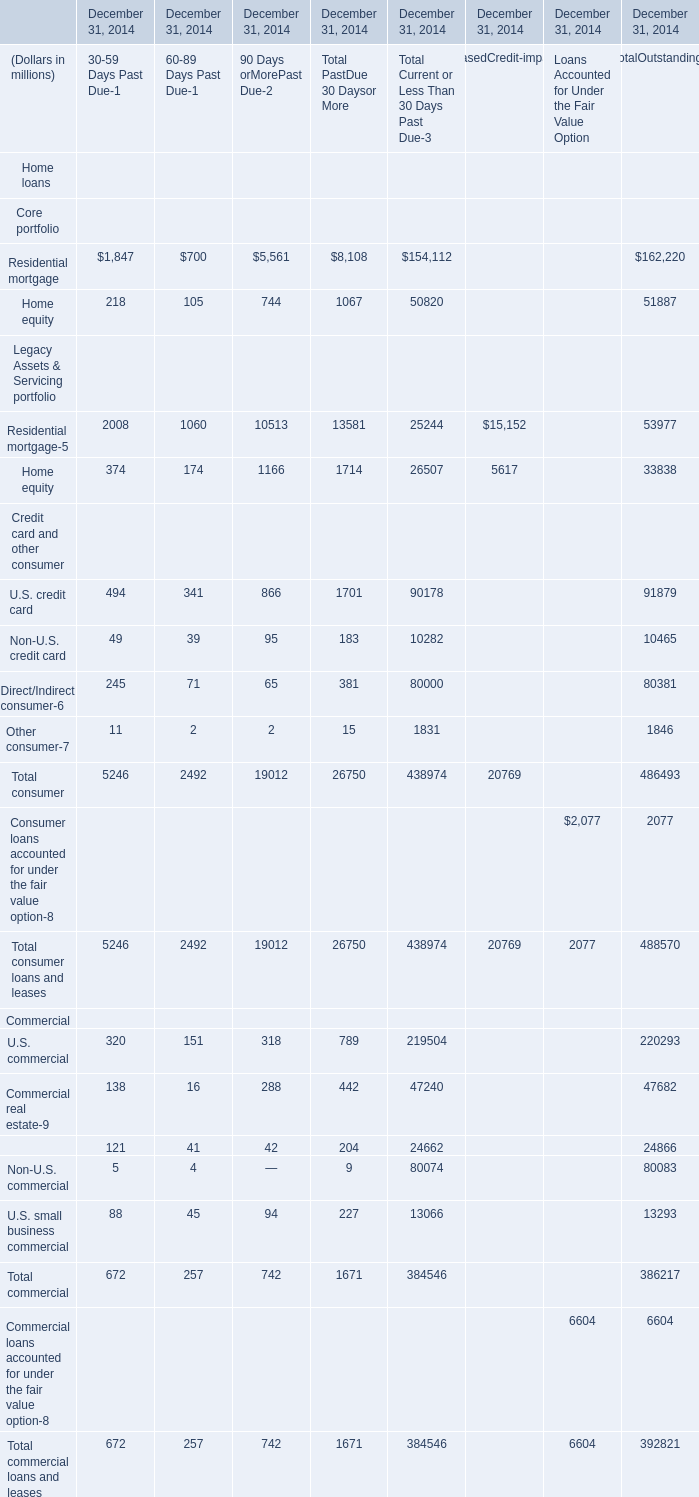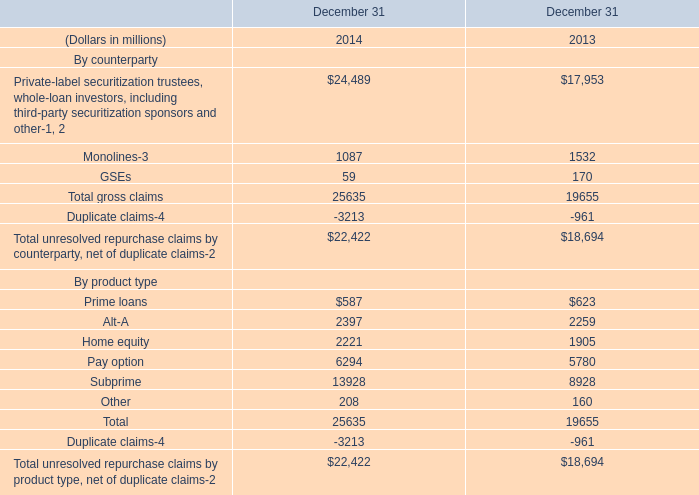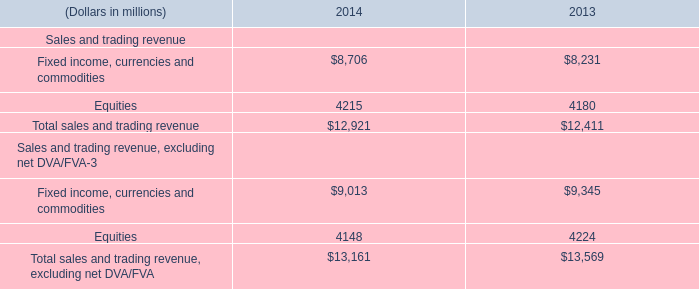What will Total loans and leases reach in 2015 if it continues to grow annually at its current rate? (in dollars in millions) 
Computations: (823520 * (1 + ((823520 - 28421) / 28421)))
Answer: 23862115.70318. 